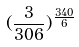<formula> <loc_0><loc_0><loc_500><loc_500>( \frac { 3 } { 3 0 6 } ) ^ { \frac { 3 4 0 } { 6 } }</formula> 